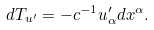<formula> <loc_0><loc_0><loc_500><loc_500>d T _ { u ^ { \prime } } = - c ^ { - 1 } u ^ { \prime } _ { \alpha } d x ^ { \alpha } .</formula> 